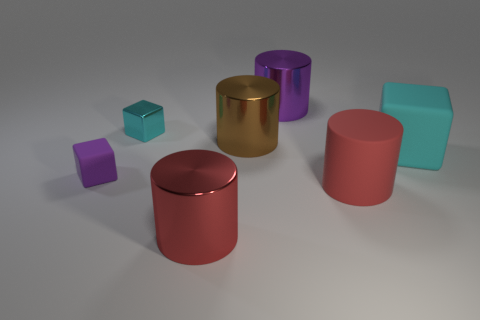Add 1 blue spheres. How many objects exist? 8 Subtract all gray cylinders. Subtract all red blocks. How many cylinders are left? 4 Subtract all cylinders. How many objects are left? 3 Add 4 large cyan things. How many large cyan things are left? 5 Add 1 large red objects. How many large red objects exist? 3 Subtract 0 yellow spheres. How many objects are left? 7 Subtract all yellow cylinders. Subtract all purple cylinders. How many objects are left? 6 